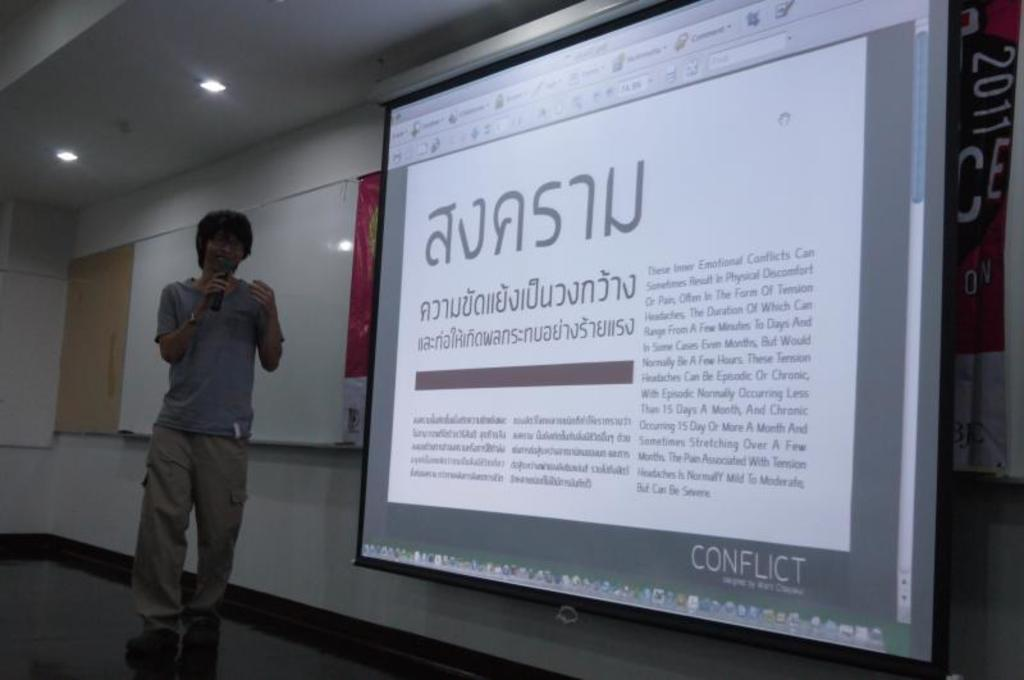What is the person in the image holding? The person is holding a mic. What is the person standing on in the image? The person is standing on a floor. What is the background of the image made of? The background of the image includes a wall. What is being used to display visuals in the image? A projector screen is present in the image. What can be seen providing illumination in the image? There are lights in the image. What else can be seen in the image besides the person and the mic? There are some objects visible in the image. What type of oranges can be seen in the image? There are no oranges present in the image. What is the person using their teeth for in the image? The person is holding a mic, and there is no indication that they are using their teeth for anything in the image. 